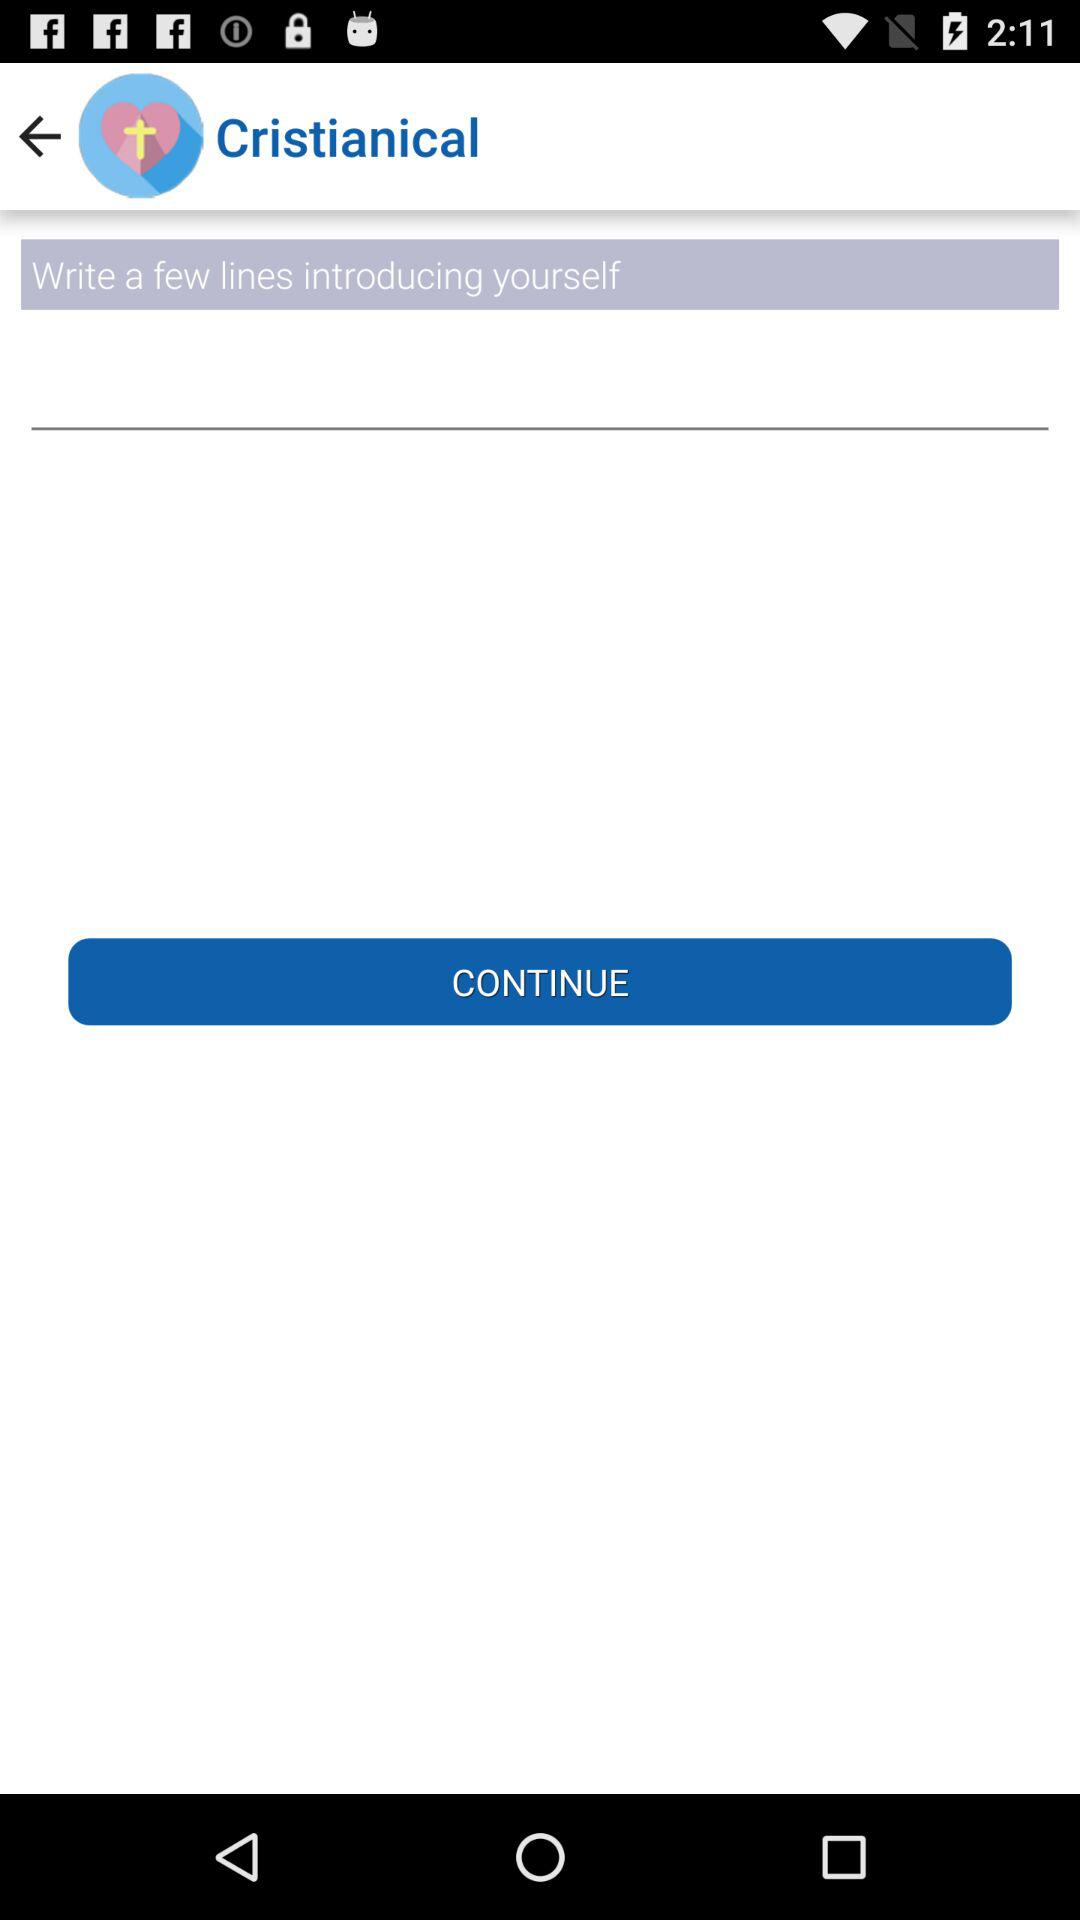What is the name of the application? The name of the application is "Cristianical". 